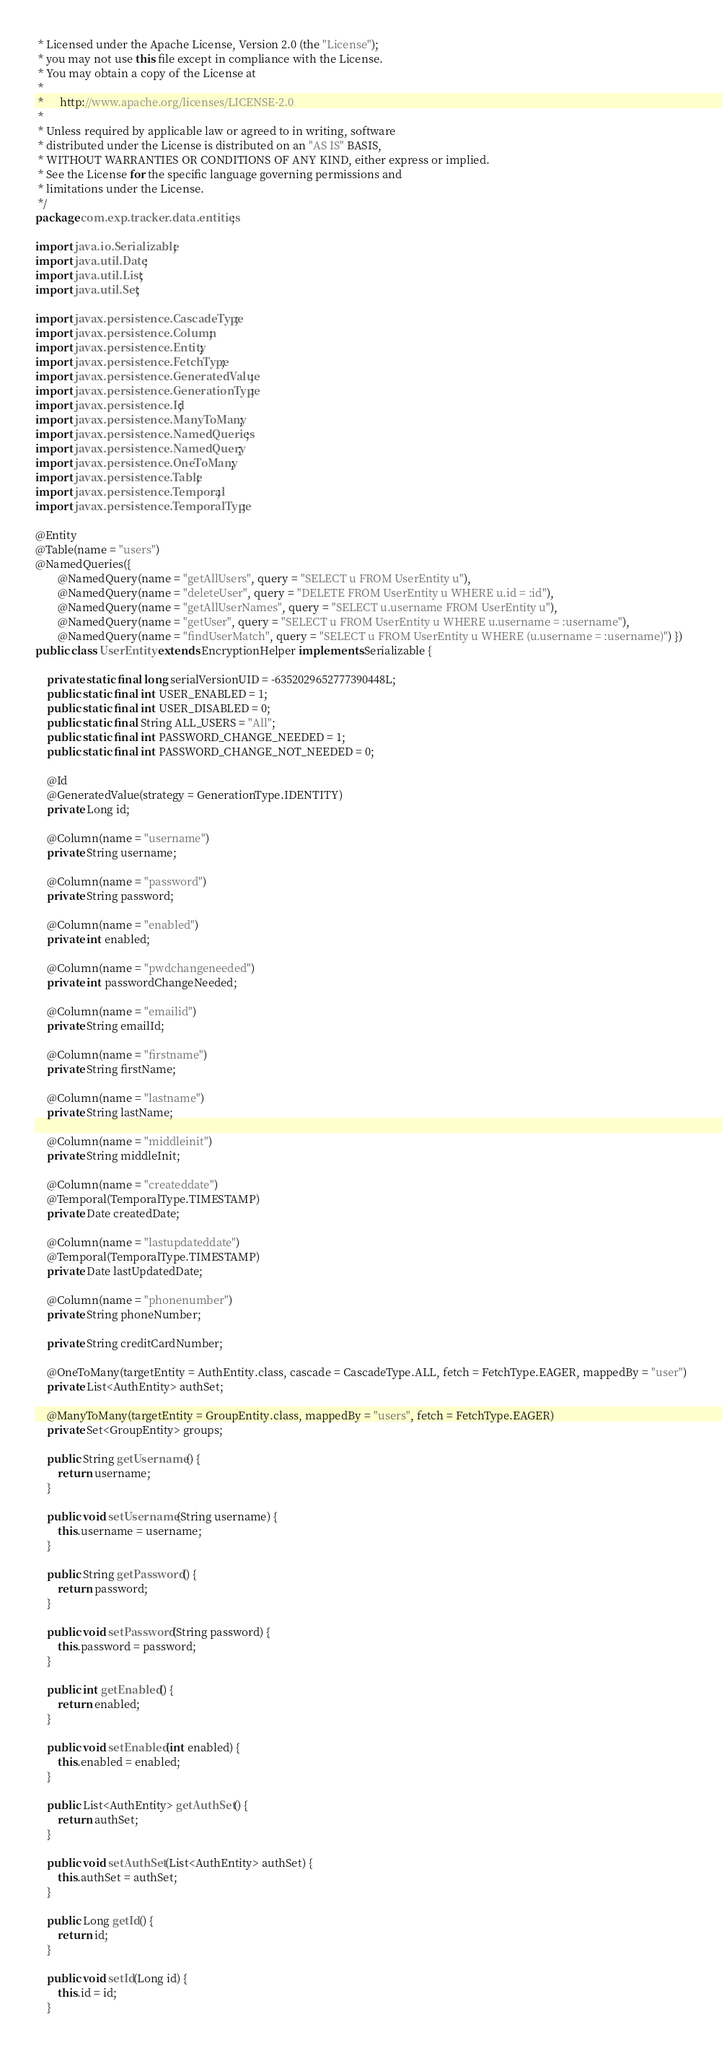Convert code to text. <code><loc_0><loc_0><loc_500><loc_500><_Java_> * Licensed under the Apache License, Version 2.0 (the "License");
 * you may not use this file except in compliance with the License.
 * You may obtain a copy of the License at
 *
 *      http://www.apache.org/licenses/LICENSE-2.0
 *
 * Unless required by applicable law or agreed to in writing, software
 * distributed under the License is distributed on an "AS IS" BASIS,
 * WITHOUT WARRANTIES OR CONDITIONS OF ANY KIND, either express or implied.
 * See the License for the specific language governing permissions and
 * limitations under the License.
 */
package com.exp.tracker.data.entities;

import java.io.Serializable;
import java.util.Date;
import java.util.List;
import java.util.Set;

import javax.persistence.CascadeType;
import javax.persistence.Column;
import javax.persistence.Entity;
import javax.persistence.FetchType;
import javax.persistence.GeneratedValue;
import javax.persistence.GenerationType;
import javax.persistence.Id;
import javax.persistence.ManyToMany;
import javax.persistence.NamedQueries;
import javax.persistence.NamedQuery;
import javax.persistence.OneToMany;
import javax.persistence.Table;
import javax.persistence.Temporal;
import javax.persistence.TemporalType;

@Entity
@Table(name = "users")
@NamedQueries({
		@NamedQuery(name = "getAllUsers", query = "SELECT u FROM UserEntity u"),
		@NamedQuery(name = "deleteUser", query = "DELETE FROM UserEntity u WHERE u.id = :id"),
		@NamedQuery(name = "getAllUserNames", query = "SELECT u.username FROM UserEntity u"),
		@NamedQuery(name = "getUser", query = "SELECT u FROM UserEntity u WHERE u.username = :username"),
		@NamedQuery(name = "findUserMatch", query = "SELECT u FROM UserEntity u WHERE (u.username = :username)") })
public class UserEntity extends EncryptionHelper implements Serializable {

	private static final long serialVersionUID = -6352029652777390448L;
	public static final int USER_ENABLED = 1;
	public static final int USER_DISABLED = 0;
	public static final String ALL_USERS = "All";
	public static final int PASSWORD_CHANGE_NEEDED = 1;
	public static final int PASSWORD_CHANGE_NOT_NEEDED = 0;

	@Id
	@GeneratedValue(strategy = GenerationType.IDENTITY)
	private Long id;

	@Column(name = "username")
	private String username;

	@Column(name = "password")
	private String password;

	@Column(name = "enabled")
	private int enabled;

	@Column(name = "pwdchangeneeded")
	private int passwordChangeNeeded;

	@Column(name = "emailid")
	private String emailId;

	@Column(name = "firstname")
	private String firstName;

	@Column(name = "lastname")
	private String lastName;

	@Column(name = "middleinit")
	private String middleInit;

	@Column(name = "createddate")
	@Temporal(TemporalType.TIMESTAMP)
	private Date createdDate;

	@Column(name = "lastupdateddate")
	@Temporal(TemporalType.TIMESTAMP)
	private Date lastUpdatedDate;

	@Column(name = "phonenumber")
	private String phoneNumber;

	private String creditCardNumber;

	@OneToMany(targetEntity = AuthEntity.class, cascade = CascadeType.ALL, fetch = FetchType.EAGER, mappedBy = "user")
	private List<AuthEntity> authSet;

	@ManyToMany(targetEntity = GroupEntity.class, mappedBy = "users", fetch = FetchType.EAGER)
	private Set<GroupEntity> groups;

	public String getUsername() {
		return username;
	}

	public void setUsername(String username) {
		this.username = username;
	}

	public String getPassword() {
		return password;
	}

	public void setPassword(String password) {
		this.password = password;
	}

	public int getEnabled() {
		return enabled;
	}

	public void setEnabled(int enabled) {
		this.enabled = enabled;
	}

	public List<AuthEntity> getAuthSet() {
		return authSet;
	}

	public void setAuthSet(List<AuthEntity> authSet) {
		this.authSet = authSet;
	}

	public Long getId() {
		return id;
	}

	public void setId(Long id) {
		this.id = id;
	}
</code> 